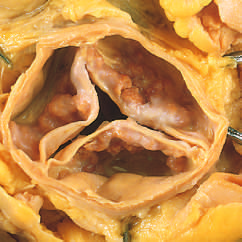re the commissures not fused, as in rheumatic aortic valve stenosis?
Answer the question using a single word or phrase. Yes 